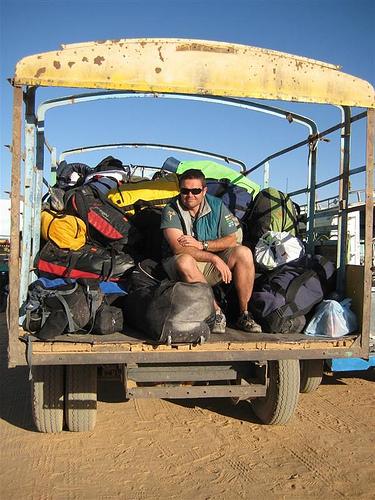Is that a bus?
Give a very brief answer. No. Is the man sitting on luggage?
Write a very short answer. Yes. Does the man usually wear a shirt when out in the sun?
Be succinct. Yes. 